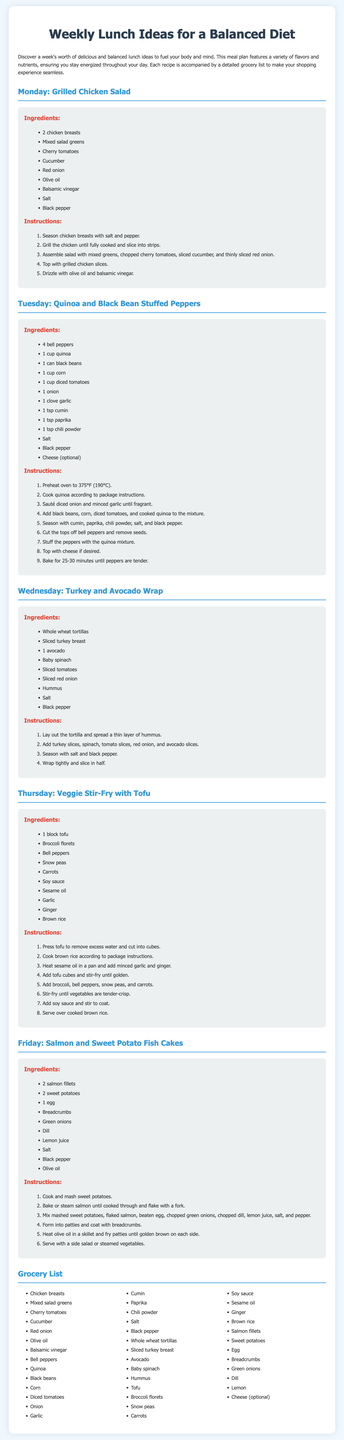What is the title of the document? The document is titled "Weekly Lunch Ideas for a Balanced Diet."
Answer: Weekly Lunch Ideas for a Balanced Diet How many lunch ideas are presented in the document? The document presents a total of five lunch ideas, one for each weekday.
Answer: Five What is one ingredient listed for the Grilled Chicken Salad? The Grilled Chicken Salad includes several ingredients, one of which is cherry tomatoes.
Answer: Cherry tomatoes What is the cooking temperature for the Quinoa and Black Bean Stuffed Peppers? The cooking temperature specified in the document for the Quinoa and Black Bean Stuffed Peppers is 375°F (190°C).
Answer: 375°F (190°C) Which ingredient is optional for Quinoa and Black Bean Stuffed Peppers? In the recipe, cheese is mentioned as an optional ingredient.
Answer: Cheese What main protein is used in the Turkey and Avocado Wrap? The main protein used in the Turkey and Avocado Wrap is sliced turkey breast.
Answer: Sliced turkey breast What type of rice is used in the Veggie Stir-Fry with Tofu? The type of rice used in the Veggie Stir-Fry with Tofu is brown rice.
Answer: Brown rice Which fish is used in the Friday recipe? The document specifies salmon fillets are used in the Friday recipe.
Answer: Salmon fillets What is the total number of ingredients listed in the grocery list? The grocery list includes a total of 40 different ingredients.
Answer: 40 